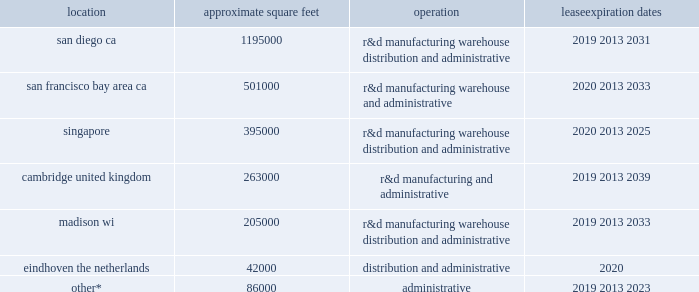Table of contents our certificate of incorporation and bylaws include anti-takeover provisions that may make it difficult for another company to acquire control of us or limit the price investors might be willing to pay for our stock .
Certain provisions of our certificate of incorporation and bylaws could delay the removal of incumbent directors and could make it more difficult to successfully complete a merger , tender offer , or proxy contest involving us .
Our certificate of incorporation has provisions that give our board the ability to issue preferred stock and determine the rights and designations of the preferred stock at any time without stockholder approval .
The rights of the holders of our common stock will be subject to , and may be adversely affected by , the rights of the holders of any preferred stock that may be issued in the future .
The issuance of preferred stock , while providing flexibility in connection with possible acquisitions and other corporate purposes , could have the effect of making it more difficult for a third party to acquire , or of discouraging a third party from acquiring , a majority of our outstanding voting stock .
In addition , the staggered terms of our board of directors could have the effect of delaying or deferring a change in control .
In addition , certain provisions of the delaware general corporation law ( dgcl ) , including section 203 of the dgcl , may have the effect of delaying or preventing changes in the control or management of illumina .
Section 203 of the dgcl provides , with certain exceptions , for waiting periods applicable to business combinations with stockholders owning at least 15% ( 15 % ) and less than 85% ( 85 % ) of the voting stock ( exclusive of stock held by directors , officers , and employee plans ) of a company .
The above factors may have the effect of deterring hostile takeovers or otherwise delaying or preventing changes in the control or management of illumina , including transactions in which our stockholders might otherwise receive a premium over the fair market value of our common stock .
Item 1b .
Unresolved staff comments .
Item 2 .
Properties .
The table summarizes the facilities we leased as of december 30 , 2018 , including the location and size of each principal facility , and their designated use .
We believe our facilities are adequate for our current and near-term needs , and we will be able to locate additional facilities , as needed .
Location approximate square feet operation expiration dates .
________________ *excludes approximately 48000 square feet for which the leases do not commence until 2019 and beyond .
Item 3 .
Legal proceedings .
See discussion of legal proceedings in note 201c7 .
Legal proceedings 201d in part ii , item 8 of this report , which is incorporated by reference herein .
Item 4 .
Mine safety disclosures .
Not applicable. .
As of december 30 , 2018 what was the percent of the other excluded lease square feet due to commencement in 2019? 
Computations: (48000 / 86000)
Answer: 0.55814. Table of contents our certificate of incorporation and bylaws include anti-takeover provisions that may make it difficult for another company to acquire control of us or limit the price investors might be willing to pay for our stock .
Certain provisions of our certificate of incorporation and bylaws could delay the removal of incumbent directors and could make it more difficult to successfully complete a merger , tender offer , or proxy contest involving us .
Our certificate of incorporation has provisions that give our board the ability to issue preferred stock and determine the rights and designations of the preferred stock at any time without stockholder approval .
The rights of the holders of our common stock will be subject to , and may be adversely affected by , the rights of the holders of any preferred stock that may be issued in the future .
The issuance of preferred stock , while providing flexibility in connection with possible acquisitions and other corporate purposes , could have the effect of making it more difficult for a third party to acquire , or of discouraging a third party from acquiring , a majority of our outstanding voting stock .
In addition , the staggered terms of our board of directors could have the effect of delaying or deferring a change in control .
In addition , certain provisions of the delaware general corporation law ( dgcl ) , including section 203 of the dgcl , may have the effect of delaying or preventing changes in the control or management of illumina .
Section 203 of the dgcl provides , with certain exceptions , for waiting periods applicable to business combinations with stockholders owning at least 15% ( 15 % ) and less than 85% ( 85 % ) of the voting stock ( exclusive of stock held by directors , officers , and employee plans ) of a company .
The above factors may have the effect of deterring hostile takeovers or otherwise delaying or preventing changes in the control or management of illumina , including transactions in which our stockholders might otherwise receive a premium over the fair market value of our common stock .
Item 1b .
Unresolved staff comments .
Item 2 .
Properties .
The table summarizes the facilities we leased as of december 30 , 2018 , including the location and size of each principal facility , and their designated use .
We believe our facilities are adequate for our current and near-term needs , and we will be able to locate additional facilities , as needed .
Location approximate square feet operation expiration dates .
________________ *excludes approximately 48000 square feet for which the leases do not commence until 2019 and beyond .
Item 3 .
Legal proceedings .
See discussion of legal proceedings in note 201c7 .
Legal proceedings 201d in part ii , item 8 of this report , which is incorporated by reference herein .
Item 4 .
Mine safety disclosures .
Not applicable. .
As of december 30 , 2018 what was the ratio of the approximate square feet operation leased in san francisco bay area ca to singapore? 
Rationale: as of december 30 , 2018 the ratio of the approximate square feet of operation leased in san francisco bay area ca to singapore was 1.3 to 1
Computations: (501000 / 395000)
Answer: 1.26835. 